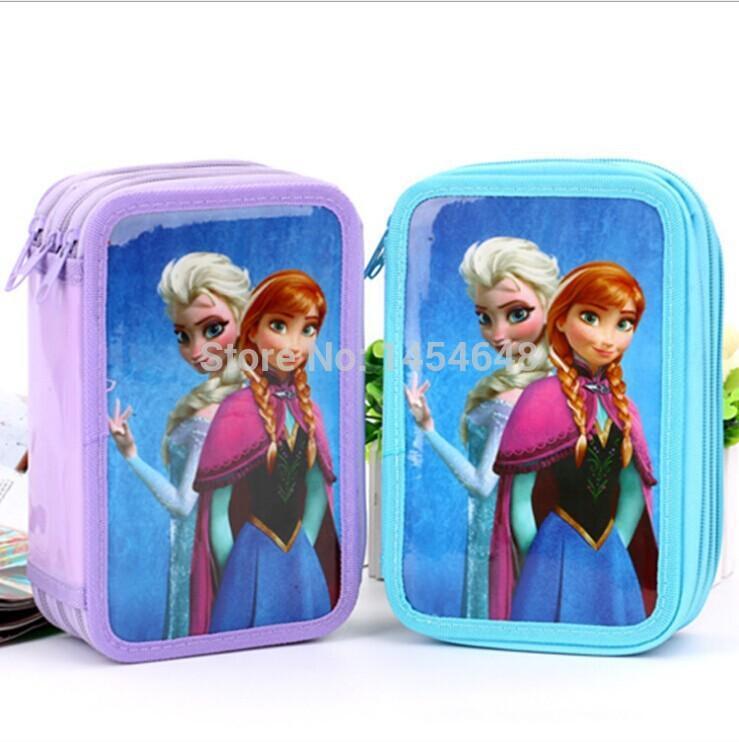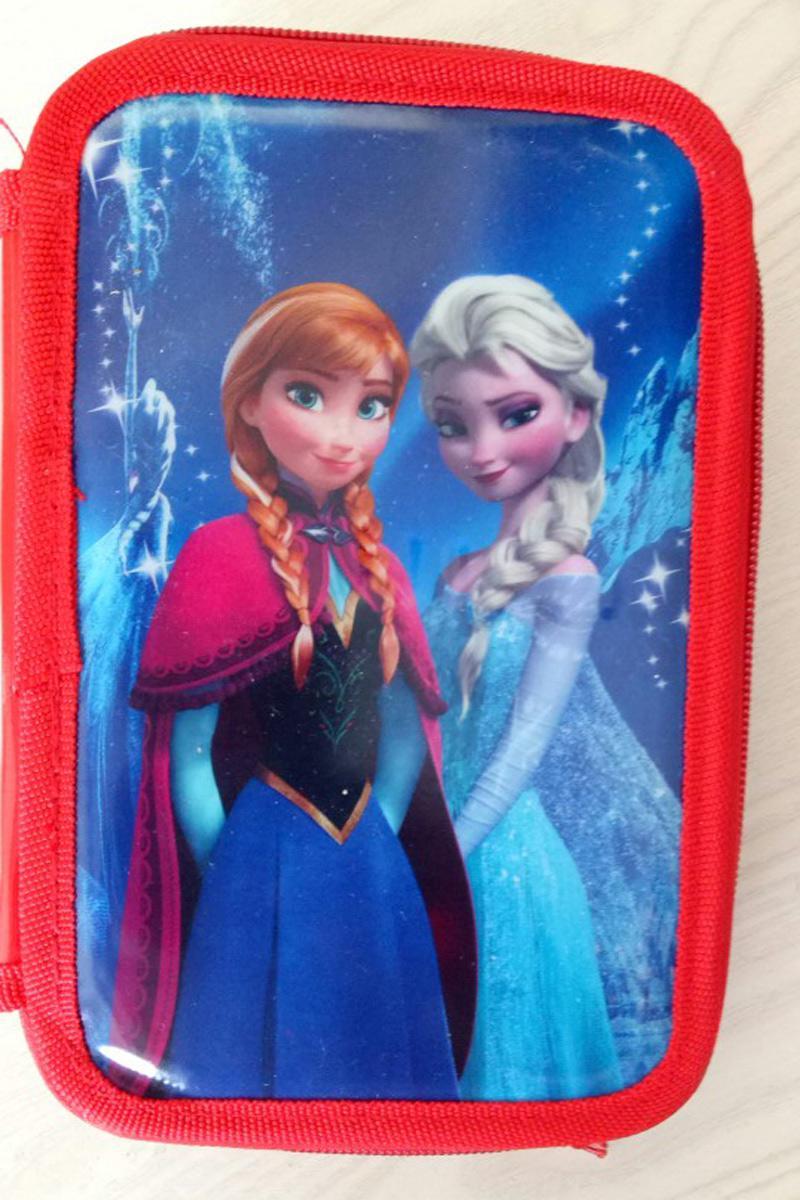The first image is the image on the left, the second image is the image on the right. Examine the images to the left and right. Is the description "There are two zippered wallets." accurate? Answer yes or no. No. The first image is the image on the left, the second image is the image on the right. For the images shown, is this caption "One of the two images has a bag with the characters from Disney's Frozen on it." true? Answer yes or no. No. 